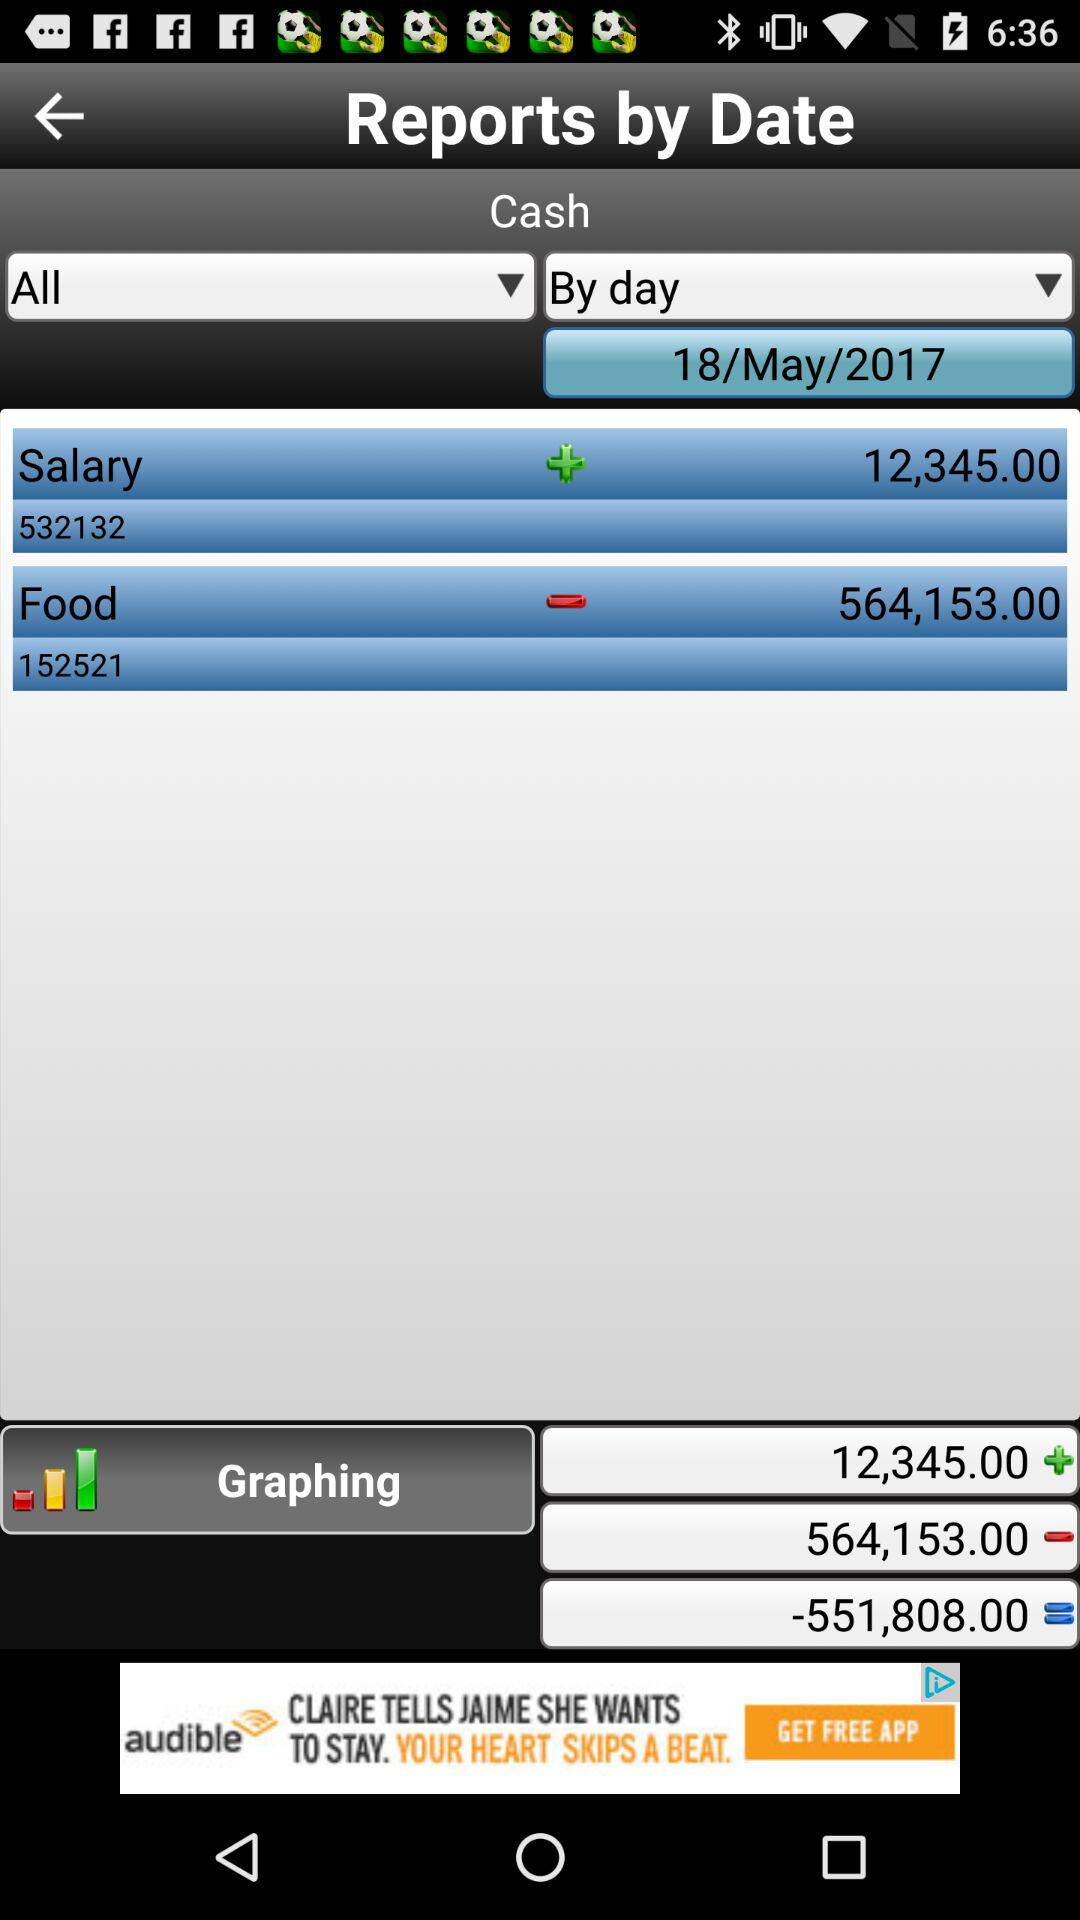The data is shown from what date? The data is shown from May 18, 2017. 